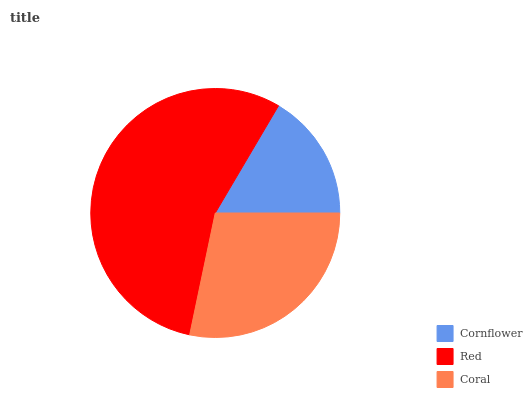Is Cornflower the minimum?
Answer yes or no. Yes. Is Red the maximum?
Answer yes or no. Yes. Is Coral the minimum?
Answer yes or no. No. Is Coral the maximum?
Answer yes or no. No. Is Red greater than Coral?
Answer yes or no. Yes. Is Coral less than Red?
Answer yes or no. Yes. Is Coral greater than Red?
Answer yes or no. No. Is Red less than Coral?
Answer yes or no. No. Is Coral the high median?
Answer yes or no. Yes. Is Coral the low median?
Answer yes or no. Yes. Is Cornflower the high median?
Answer yes or no. No. Is Cornflower the low median?
Answer yes or no. No. 